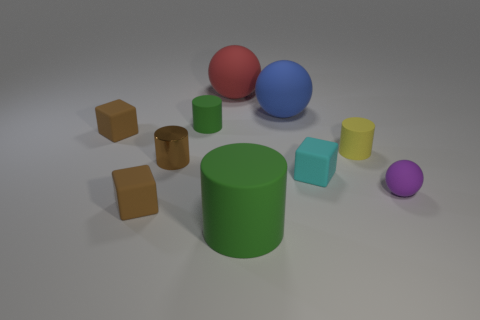Subtract all purple spheres. How many spheres are left? 2 Subtract all yellow cylinders. How many cylinders are left? 3 Subtract 3 cubes. How many cubes are left? 0 Subtract all cubes. How many objects are left? 7 Subtract all red cylinders. How many green spheres are left? 0 Subtract all metallic objects. Subtract all blue spheres. How many objects are left? 8 Add 5 big red spheres. How many big red spheres are left? 6 Add 9 tiny brown metal things. How many tiny brown metal things exist? 10 Subtract 2 brown cubes. How many objects are left? 8 Subtract all blue spheres. Subtract all cyan cylinders. How many spheres are left? 2 